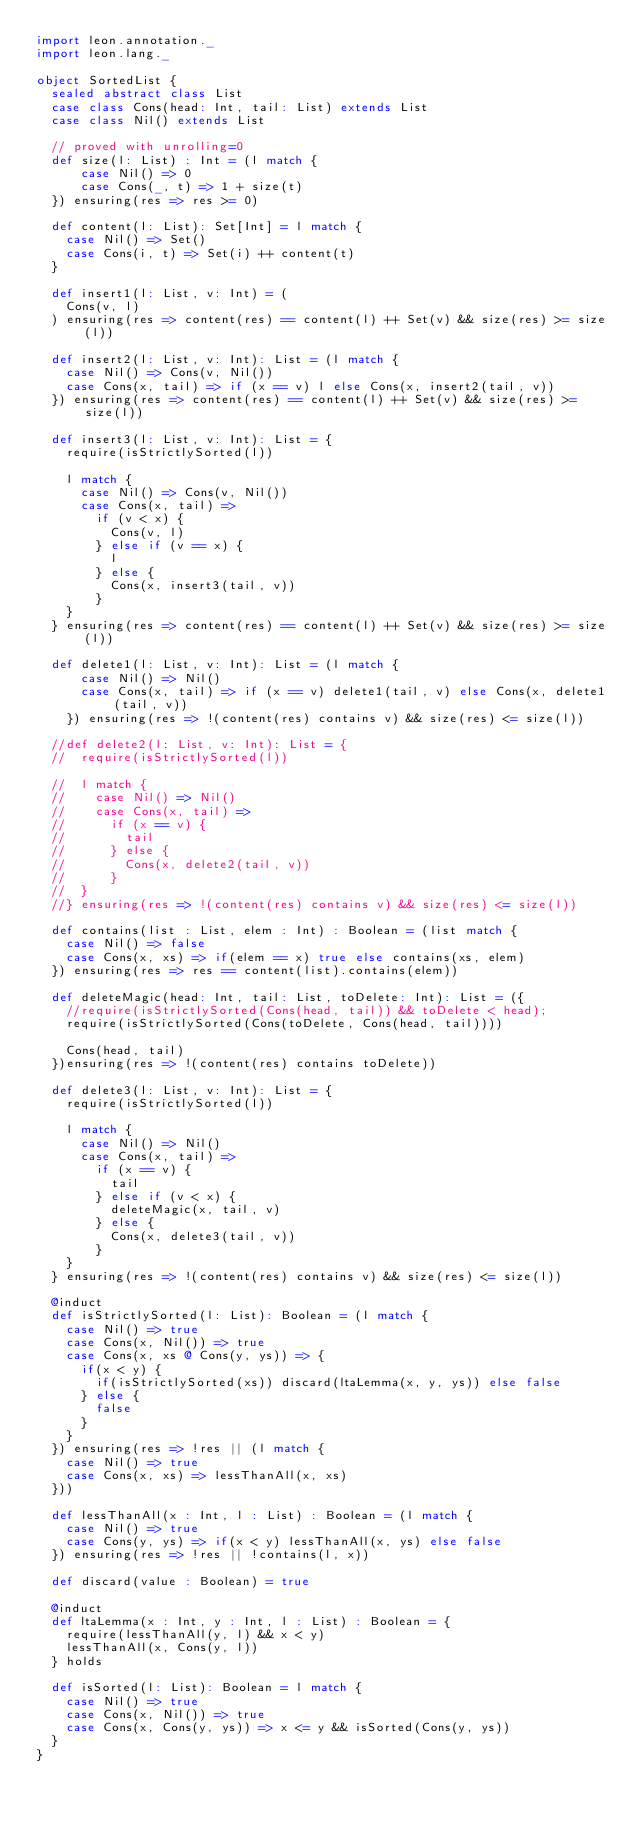<code> <loc_0><loc_0><loc_500><loc_500><_Scala_>import leon.annotation._
import leon.lang._

object SortedList {
  sealed abstract class List
  case class Cons(head: Int, tail: List) extends List
  case class Nil() extends List

  // proved with unrolling=0
  def size(l: List) : Int = (l match {
      case Nil() => 0
      case Cons(_, t) => 1 + size(t)
  }) ensuring(res => res >= 0)

  def content(l: List): Set[Int] = l match {
    case Nil() => Set()
    case Cons(i, t) => Set(i) ++ content(t)
  }

  def insert1(l: List, v: Int) = (
    Cons(v, l)
  ) ensuring(res => content(res) == content(l) ++ Set(v) && size(res) >= size(l))

  def insert2(l: List, v: Int): List = (l match {
    case Nil() => Cons(v, Nil())
    case Cons(x, tail) => if (x == v) l else Cons(x, insert2(tail, v))
  }) ensuring(res => content(res) == content(l) ++ Set(v) && size(res) >= size(l))

  def insert3(l: List, v: Int): List = {
    require(isStrictlySorted(l))

    l match {
      case Nil() => Cons(v, Nil())
      case Cons(x, tail) =>
        if (v < x) {
          Cons(v, l)
        } else if (v == x) {
          l
        } else {
          Cons(x, insert3(tail, v))
        }
    }
  } ensuring(res => content(res) == content(l) ++ Set(v) && size(res) >= size(l))

  def delete1(l: List, v: Int): List = (l match {
      case Nil() => Nil()
      case Cons(x, tail) => if (x == v) delete1(tail, v) else Cons(x, delete1(tail, v))
    }) ensuring(res => !(content(res) contains v) && size(res) <= size(l))

  //def delete2(l: List, v: Int): List = {
  //  require(isStrictlySorted(l))

  //  l match {
  //    case Nil() => Nil()
  //    case Cons(x, tail) =>
  //      if (x == v) {
  //        tail
  //      } else {
  //        Cons(x, delete2(tail, v))
  //      }
  //  }
  //} ensuring(res => !(content(res) contains v) && size(res) <= size(l))

  def contains(list : List, elem : Int) : Boolean = (list match {
    case Nil() => false
    case Cons(x, xs) => if(elem == x) true else contains(xs, elem)
  }) ensuring(res => res == content(list).contains(elem))

  def deleteMagic(head: Int, tail: List, toDelete: Int): List = ({
    //require(isStrictlySorted(Cons(head, tail)) && toDelete < head);
    require(isStrictlySorted(Cons(toDelete, Cons(head, tail))))

    Cons(head, tail)
  })ensuring(res => !(content(res) contains toDelete))

  def delete3(l: List, v: Int): List = {
    require(isStrictlySorted(l))

    l match {
      case Nil() => Nil()
      case Cons(x, tail) =>
        if (x == v) {
          tail
        } else if (v < x) {
          deleteMagic(x, tail, v)
        } else {
          Cons(x, delete3(tail, v))
        }
    }
  } ensuring(res => !(content(res) contains v) && size(res) <= size(l))

  @induct
  def isStrictlySorted(l: List): Boolean = (l match {
    case Nil() => true
    case Cons(x, Nil()) => true
    case Cons(x, xs @ Cons(y, ys)) => {
      if(x < y) {
        if(isStrictlySorted(xs)) discard(ltaLemma(x, y, ys)) else false
      } else {
        false
      }
    }
  }) ensuring(res => !res || (l match {
    case Nil() => true
    case Cons(x, xs) => lessThanAll(x, xs)
  }))

  def lessThanAll(x : Int, l : List) : Boolean = (l match {
    case Nil() => true
    case Cons(y, ys) => if(x < y) lessThanAll(x, ys) else false
  }) ensuring(res => !res || !contains(l, x))

  def discard(value : Boolean) = true

  @induct
  def ltaLemma(x : Int, y : Int, l : List) : Boolean = {
    require(lessThanAll(y, l) && x < y)
    lessThanAll(x, Cons(y, l))
  } holds

  def isSorted(l: List): Boolean = l match {
    case Nil() => true
    case Cons(x, Nil()) => true
    case Cons(x, Cons(y, ys)) => x <= y && isSorted(Cons(y, ys))
  }
}
</code> 